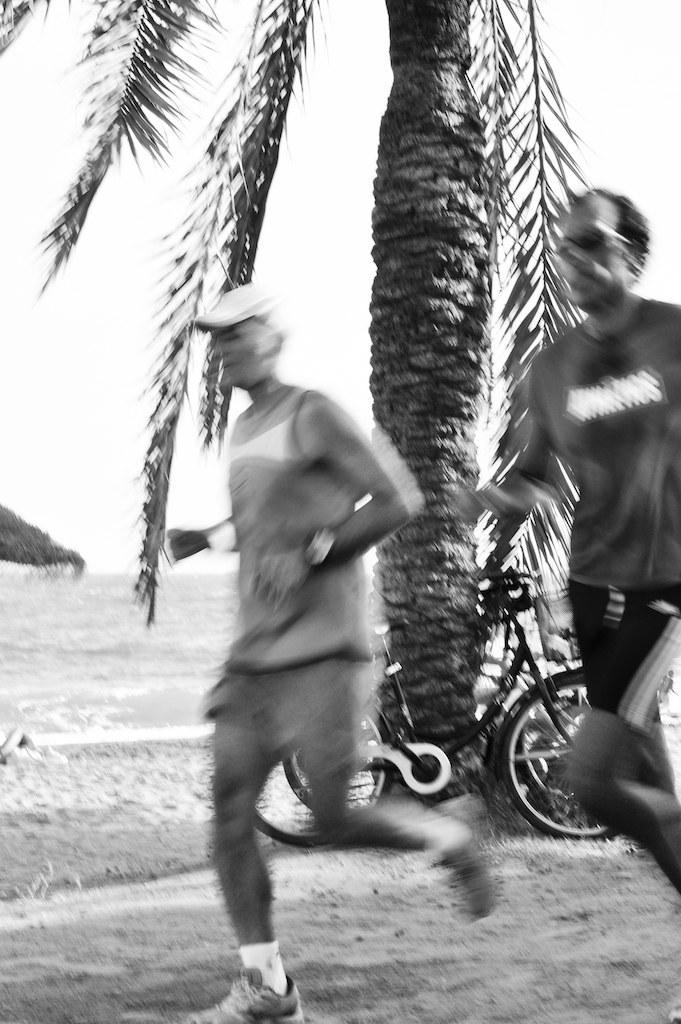What is the color scheme of the image? The image is black and white. What are the two people in the image doing? The two people are running in the image. Where are the people running? The people are running on a path. What else can be seen in the image besides the people running? There is a bicycle, a tree, and a hut in the background of the image. What type of wine is being served at the picnic in the image? There is no picnic or wine present in the image; it features two people running on a path. What type of silk fabric is draped over the hut in the image? There is no silk fabric present in the image; the hut is visible in the background, but no details about its appearance are mentioned. 